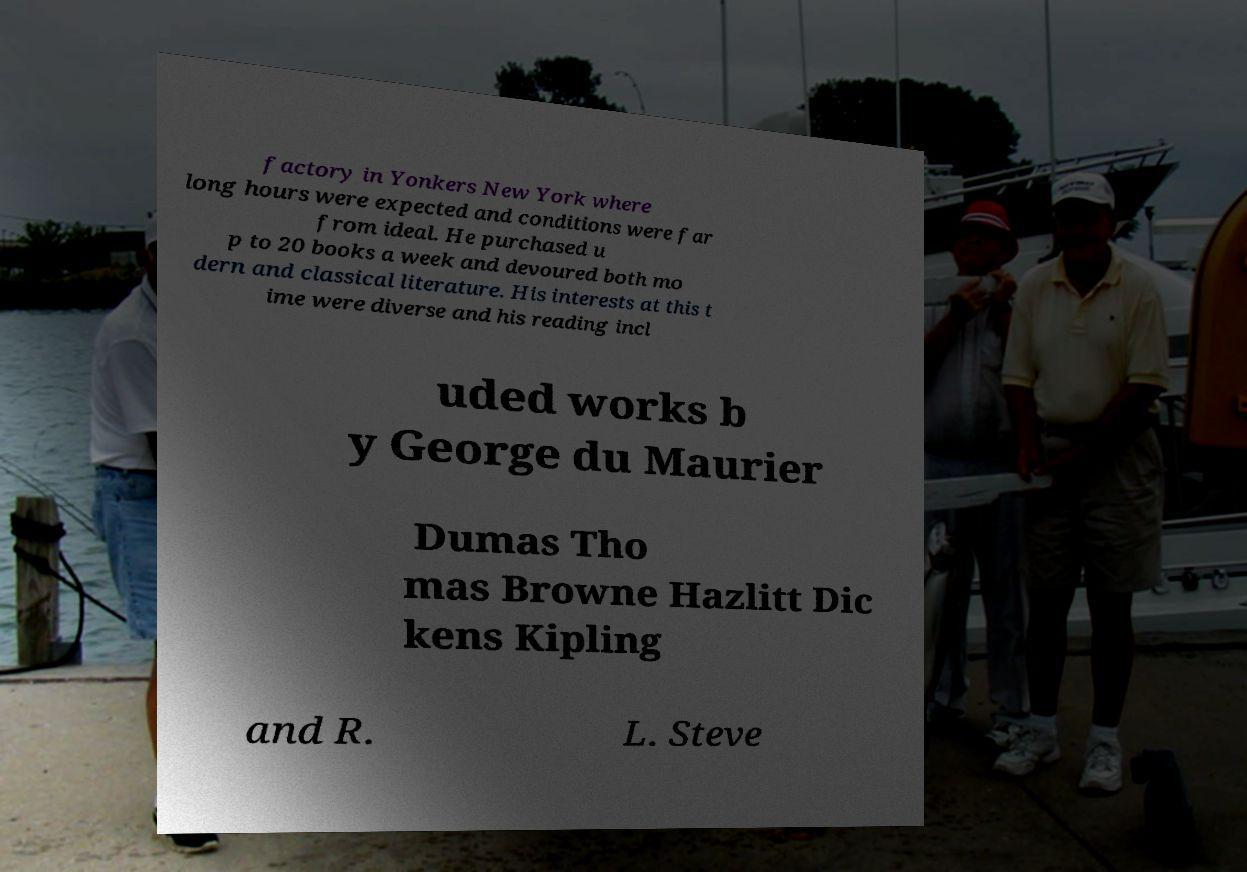Can you accurately transcribe the text from the provided image for me? factory in Yonkers New York where long hours were expected and conditions were far from ideal. He purchased u p to 20 books a week and devoured both mo dern and classical literature. His interests at this t ime were diverse and his reading incl uded works b y George du Maurier Dumas Tho mas Browne Hazlitt Dic kens Kipling and R. L. Steve 